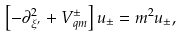Convert formula to latex. <formula><loc_0><loc_0><loc_500><loc_500>\left [ - \partial ^ { 2 } _ { \xi ^ { \prime } } + V ^ { \pm } _ { q m } \right ] u _ { \pm } = m ^ { 2 } u _ { \pm } ,</formula> 